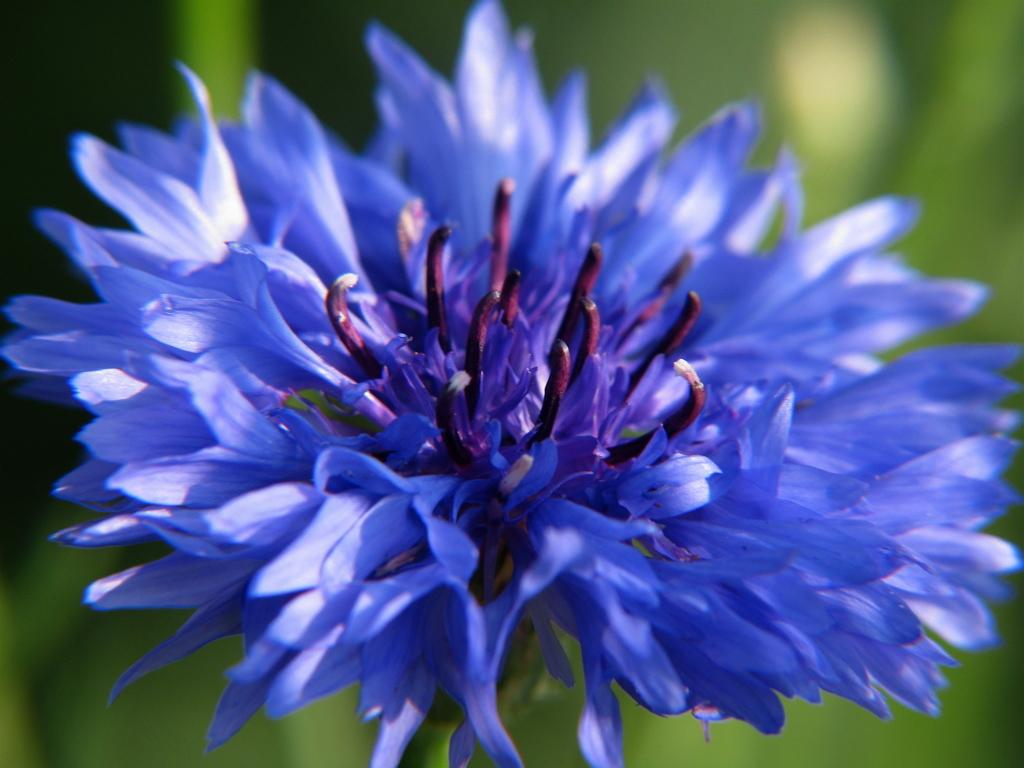What type of flower is present in the image? There is a blue color flower in the image. What is the color of the buds on the flower? The buds on the flower are violet color. What color is the background of the image? The background of the image is green. What type of produce is visible in the image? There is no produce present in the image; it features a blue color flower with violet buds against a green background. What kind of shoe can be seen on the flower? There are no shoes present in the image; it is a photograph of a flower. 